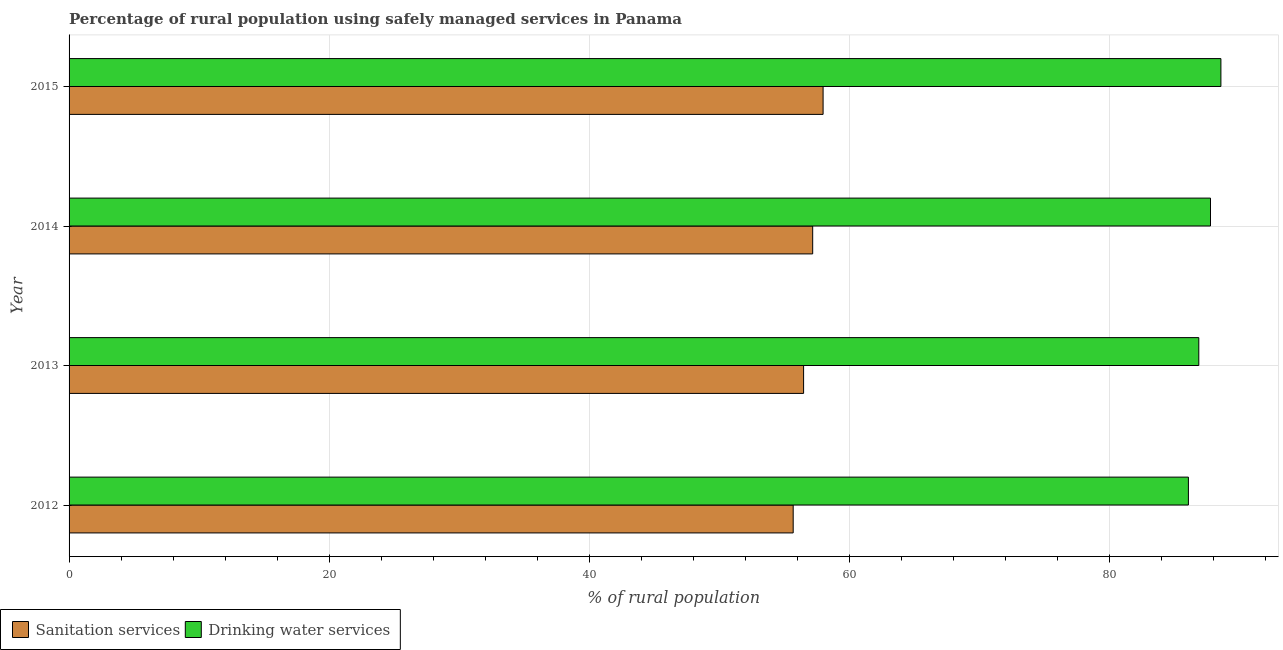Are the number of bars per tick equal to the number of legend labels?
Provide a succinct answer. Yes. Are the number of bars on each tick of the Y-axis equal?
Keep it short and to the point. Yes. In how many cases, is the number of bars for a given year not equal to the number of legend labels?
Keep it short and to the point. 0. What is the percentage of rural population who used drinking water services in 2013?
Offer a terse response. 86.9. Across all years, what is the maximum percentage of rural population who used sanitation services?
Provide a succinct answer. 58. Across all years, what is the minimum percentage of rural population who used sanitation services?
Your answer should be compact. 55.7. In which year was the percentage of rural population who used sanitation services maximum?
Give a very brief answer. 2015. What is the total percentage of rural population who used drinking water services in the graph?
Provide a short and direct response. 349.4. What is the difference between the percentage of rural population who used sanitation services in 2013 and that in 2014?
Provide a succinct answer. -0.7. What is the difference between the percentage of rural population who used sanitation services in 2014 and the percentage of rural population who used drinking water services in 2012?
Ensure brevity in your answer.  -28.9. What is the average percentage of rural population who used drinking water services per year?
Provide a short and direct response. 87.35. In the year 2015, what is the difference between the percentage of rural population who used drinking water services and percentage of rural population who used sanitation services?
Ensure brevity in your answer.  30.6. In how many years, is the percentage of rural population who used sanitation services greater than 12 %?
Provide a short and direct response. 4. What is the ratio of the percentage of rural population who used sanitation services in 2014 to that in 2015?
Ensure brevity in your answer.  0.99. Is the percentage of rural population who used drinking water services in 2013 less than that in 2015?
Keep it short and to the point. Yes. Is the difference between the percentage of rural population who used drinking water services in 2012 and 2014 greater than the difference between the percentage of rural population who used sanitation services in 2012 and 2014?
Keep it short and to the point. No. What is the difference between the highest and the lowest percentage of rural population who used sanitation services?
Provide a short and direct response. 2.3. In how many years, is the percentage of rural population who used sanitation services greater than the average percentage of rural population who used sanitation services taken over all years?
Give a very brief answer. 2. What does the 2nd bar from the top in 2012 represents?
Provide a short and direct response. Sanitation services. What does the 1st bar from the bottom in 2013 represents?
Your response must be concise. Sanitation services. Are all the bars in the graph horizontal?
Your response must be concise. Yes. What is the difference between two consecutive major ticks on the X-axis?
Provide a succinct answer. 20. Are the values on the major ticks of X-axis written in scientific E-notation?
Offer a terse response. No. Does the graph contain grids?
Keep it short and to the point. Yes. How many legend labels are there?
Provide a succinct answer. 2. How are the legend labels stacked?
Your answer should be compact. Horizontal. What is the title of the graph?
Ensure brevity in your answer.  Percentage of rural population using safely managed services in Panama. What is the label or title of the X-axis?
Provide a succinct answer. % of rural population. What is the label or title of the Y-axis?
Your answer should be compact. Year. What is the % of rural population of Sanitation services in 2012?
Make the answer very short. 55.7. What is the % of rural population in Drinking water services in 2012?
Ensure brevity in your answer.  86.1. What is the % of rural population in Sanitation services in 2013?
Offer a terse response. 56.5. What is the % of rural population of Drinking water services in 2013?
Ensure brevity in your answer.  86.9. What is the % of rural population of Sanitation services in 2014?
Your answer should be very brief. 57.2. What is the % of rural population in Drinking water services in 2014?
Offer a terse response. 87.8. What is the % of rural population in Sanitation services in 2015?
Offer a terse response. 58. What is the % of rural population in Drinking water services in 2015?
Your answer should be very brief. 88.6. Across all years, what is the maximum % of rural population in Sanitation services?
Your response must be concise. 58. Across all years, what is the maximum % of rural population of Drinking water services?
Your answer should be very brief. 88.6. Across all years, what is the minimum % of rural population in Sanitation services?
Keep it short and to the point. 55.7. Across all years, what is the minimum % of rural population in Drinking water services?
Offer a very short reply. 86.1. What is the total % of rural population of Sanitation services in the graph?
Your answer should be compact. 227.4. What is the total % of rural population in Drinking water services in the graph?
Keep it short and to the point. 349.4. What is the difference between the % of rural population in Drinking water services in 2012 and that in 2013?
Offer a very short reply. -0.8. What is the difference between the % of rural population of Sanitation services in 2012 and that in 2014?
Your answer should be very brief. -1.5. What is the difference between the % of rural population of Drinking water services in 2012 and that in 2014?
Provide a succinct answer. -1.7. What is the difference between the % of rural population of Drinking water services in 2012 and that in 2015?
Offer a very short reply. -2.5. What is the difference between the % of rural population in Drinking water services in 2013 and that in 2014?
Offer a terse response. -0.9. What is the difference between the % of rural population of Drinking water services in 2013 and that in 2015?
Give a very brief answer. -1.7. What is the difference between the % of rural population in Sanitation services in 2014 and that in 2015?
Your response must be concise. -0.8. What is the difference between the % of rural population in Sanitation services in 2012 and the % of rural population in Drinking water services in 2013?
Make the answer very short. -31.2. What is the difference between the % of rural population in Sanitation services in 2012 and the % of rural population in Drinking water services in 2014?
Make the answer very short. -32.1. What is the difference between the % of rural population in Sanitation services in 2012 and the % of rural population in Drinking water services in 2015?
Provide a succinct answer. -32.9. What is the difference between the % of rural population of Sanitation services in 2013 and the % of rural population of Drinking water services in 2014?
Make the answer very short. -31.3. What is the difference between the % of rural population in Sanitation services in 2013 and the % of rural population in Drinking water services in 2015?
Your answer should be compact. -32.1. What is the difference between the % of rural population in Sanitation services in 2014 and the % of rural population in Drinking water services in 2015?
Your answer should be compact. -31.4. What is the average % of rural population of Sanitation services per year?
Provide a succinct answer. 56.85. What is the average % of rural population of Drinking water services per year?
Your answer should be compact. 87.35. In the year 2012, what is the difference between the % of rural population in Sanitation services and % of rural population in Drinking water services?
Provide a short and direct response. -30.4. In the year 2013, what is the difference between the % of rural population in Sanitation services and % of rural population in Drinking water services?
Offer a terse response. -30.4. In the year 2014, what is the difference between the % of rural population of Sanitation services and % of rural population of Drinking water services?
Offer a very short reply. -30.6. In the year 2015, what is the difference between the % of rural population in Sanitation services and % of rural population in Drinking water services?
Offer a terse response. -30.6. What is the ratio of the % of rural population in Sanitation services in 2012 to that in 2013?
Make the answer very short. 0.99. What is the ratio of the % of rural population of Sanitation services in 2012 to that in 2014?
Provide a succinct answer. 0.97. What is the ratio of the % of rural population of Drinking water services in 2012 to that in 2014?
Make the answer very short. 0.98. What is the ratio of the % of rural population of Sanitation services in 2012 to that in 2015?
Offer a very short reply. 0.96. What is the ratio of the % of rural population of Drinking water services in 2012 to that in 2015?
Your response must be concise. 0.97. What is the ratio of the % of rural population in Drinking water services in 2013 to that in 2014?
Offer a terse response. 0.99. What is the ratio of the % of rural population in Sanitation services in 2013 to that in 2015?
Provide a short and direct response. 0.97. What is the ratio of the % of rural population in Drinking water services in 2013 to that in 2015?
Your answer should be compact. 0.98. What is the ratio of the % of rural population in Sanitation services in 2014 to that in 2015?
Give a very brief answer. 0.99. What is the ratio of the % of rural population of Drinking water services in 2014 to that in 2015?
Keep it short and to the point. 0.99. What is the difference between the highest and the lowest % of rural population in Drinking water services?
Your answer should be compact. 2.5. 